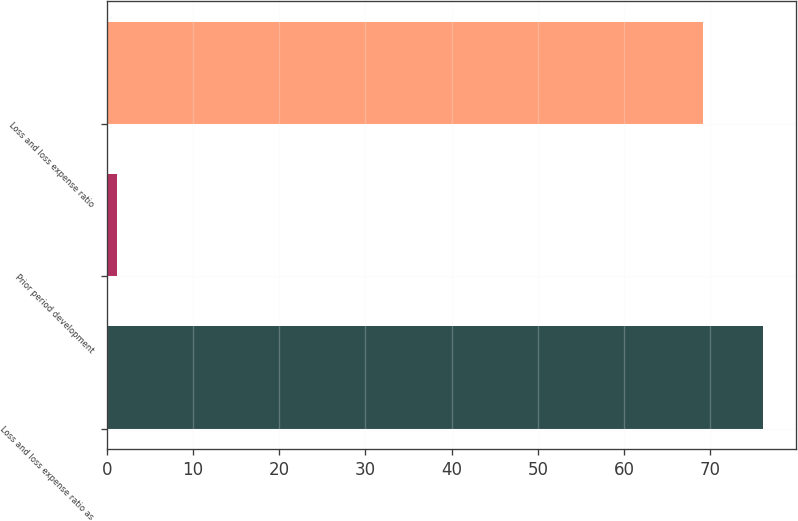<chart> <loc_0><loc_0><loc_500><loc_500><bar_chart><fcel>Loss and loss expense ratio as<fcel>Prior period development<fcel>Loss and loss expense ratio<nl><fcel>76.12<fcel>1.2<fcel>69.2<nl></chart> 